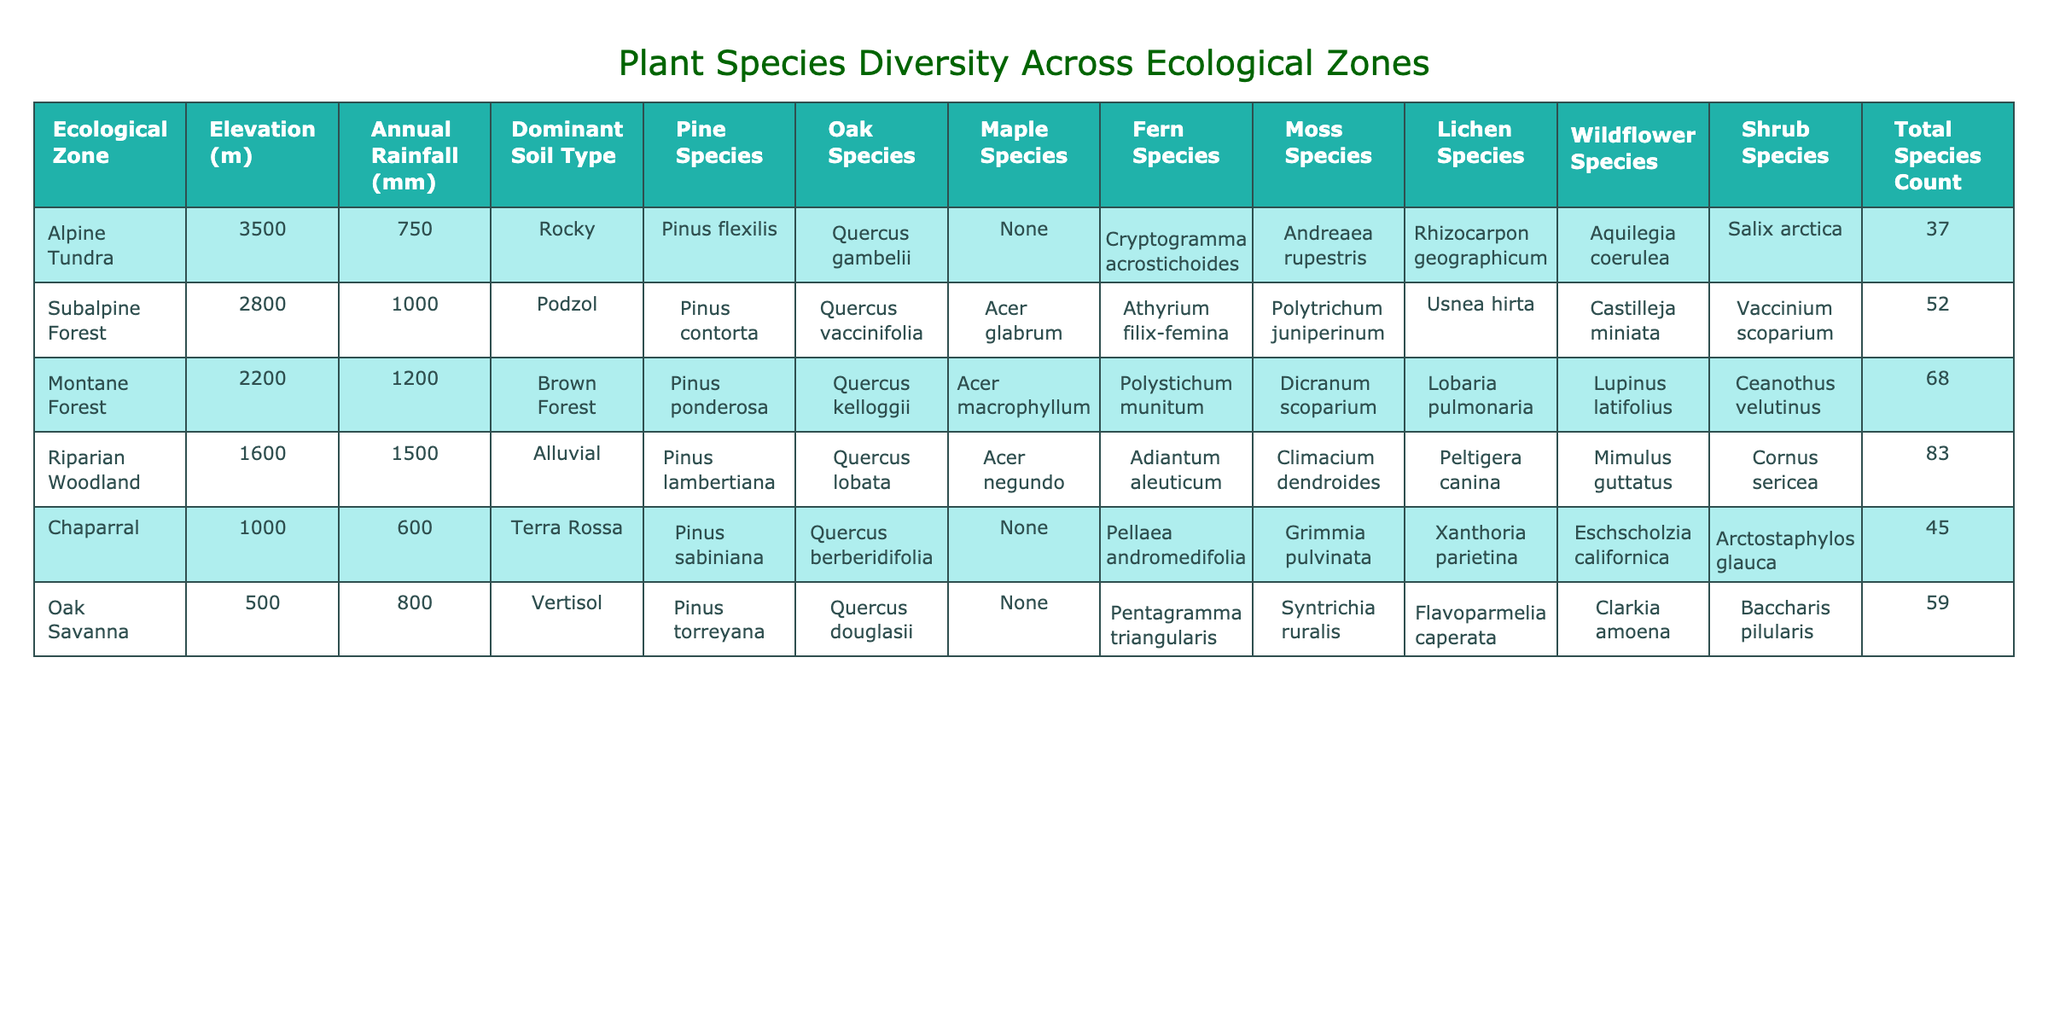What is the total species count in the Riparian Woodland? The table indicates that in the Riparian Woodland, the Total Species Count column lists the value of 83.
Answer: 83 Which ecological zone has the highest annual rainfall? By comparing the Annual Rainfall values, Riparian Woodland has the highest value at 1500 mm, compared to other zones.
Answer: Riparian Woodland Is there a Maple species listed in the Alpine Tundra? The Maple Species column for Alpine Tundra shows 'None', indicating there are no Maple species present in that zone.
Answer: No What is the difference in Total Species Count between Montane Forest and Chaparral? The Total Species Count for Montane Forest is 68 and for Chaparral is 45. The difference is 68 - 45 = 23.
Answer: 23 How many Pine species are listed in the Subalpine Forest? The data shows that the Subalpine Forest has one Pine species listed, which is Pinus contorta.
Answer: 1 Which ecological zone has the lowest elevation, and what is its Total Species Count? The lowest elevation listed is 500 m in the Oak Savanna, which has a Total Species Count of 59.
Answer: Oak Savanna, 59 Of all the ecological zones, which has the most diverse group of wildflower species, and how many are there? The Riparian Woodland has the most wildflower species listed at 6 (Mimulus guttatus, Cornus sericea), which is more than other zones.
Answer: Riparian Woodland, 6 Calculate the average annual rainfall for the Oak Savanna and Chaparral. The annual rainfall for Oak Savanna is 800 mm and for Chaparral is 600 mm. The sum is 800 + 600 = 1400 mm, and dividing by 2 gives an average of 700 mm.
Answer: 700 mm Is Quercus gambelii the only Oak species present in the given zones? By examining the Oak Species column, it is clear that multiple Oak species are present, including Quercus lobata and Quercus berberidifolia in other zones.
Answer: No What is the relationship between elevation and Total Species Count in the table? As elevation decreases from Alpine Tundra to Oak Savanna, the Total Species Count increases until a peak at Riparian Woodland, suggesting diversity increases with lower elevation, up to a point.
Answer: Elevation inversely relates to Total Species Count to a degree 